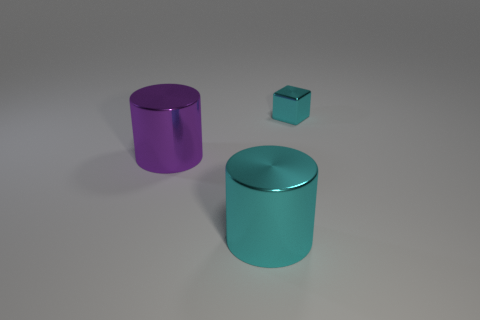Add 3 cyan blocks. How many objects exist? 6 Subtract all cylinders. How many objects are left? 1 Subtract 0 cyan spheres. How many objects are left? 3 Subtract all red metal blocks. Subtract all shiny blocks. How many objects are left? 2 Add 3 large cylinders. How many large cylinders are left? 5 Add 1 cylinders. How many cylinders exist? 3 